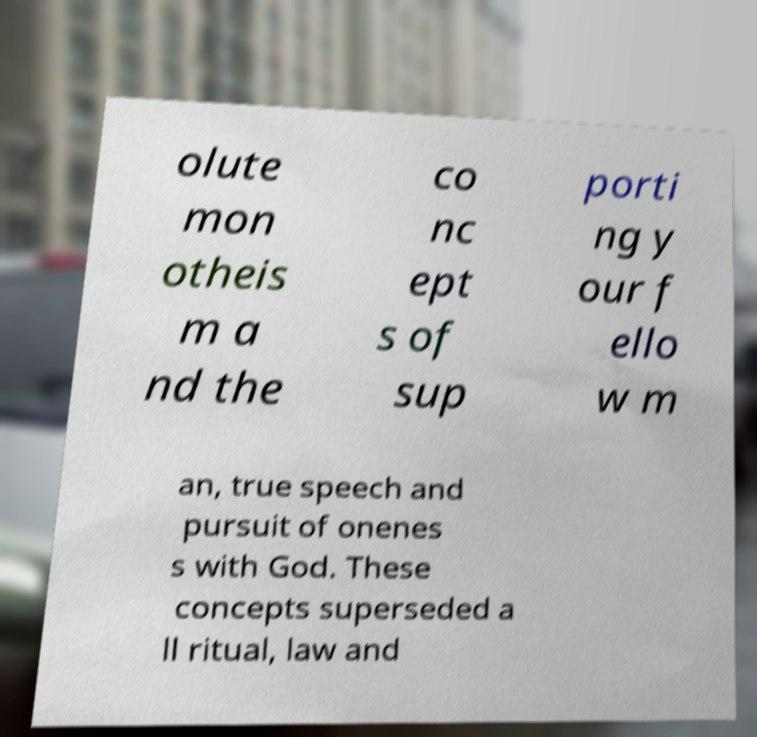Can you read and provide the text displayed in the image?This photo seems to have some interesting text. Can you extract and type it out for me? olute mon otheis m a nd the co nc ept s of sup porti ng y our f ello w m an, true speech and pursuit of onenes s with God. These concepts superseded a ll ritual, law and 